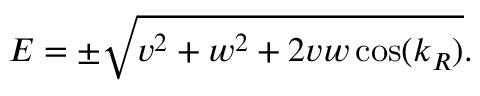<formula> <loc_0><loc_0><loc_500><loc_500>E = \pm \sqrt { v ^ { 2 } + w ^ { 2 } + 2 v w \cos ( k _ { R } ) } .</formula> 